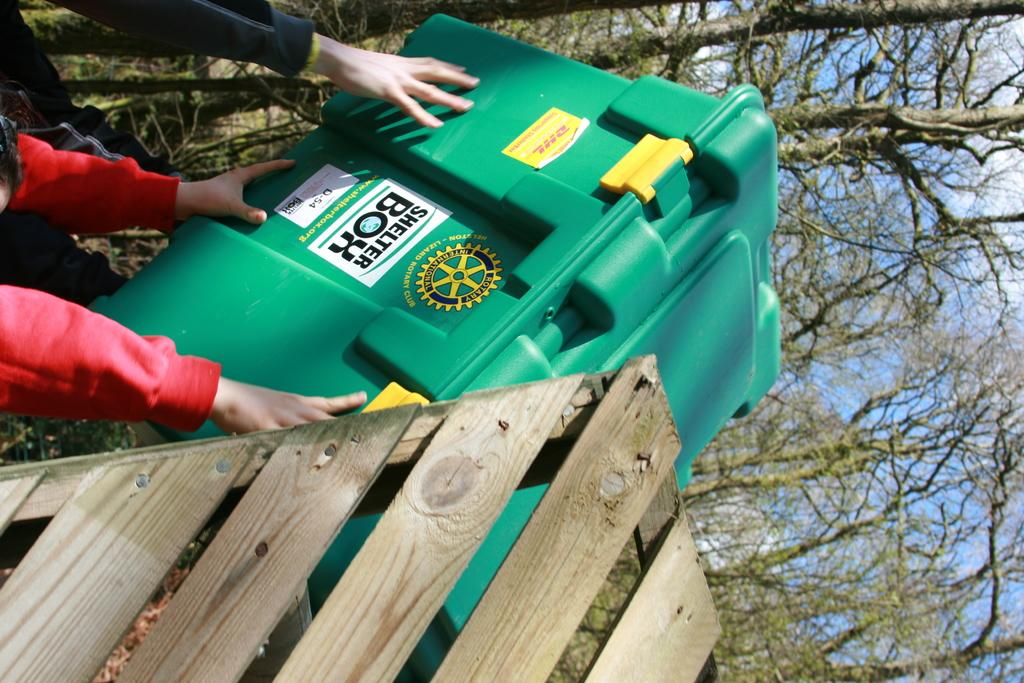What is located on the left side of the image? There is a shelter box on the left side of the image. Can you describe the people visible in the image? There are people visible in the image, but their specific actions or characteristics are not mentioned in the provided facts. What can be seen in the background of the image? There are trees in the background of the image. What type of toy can be seen in the history section of the image? There is no toy or history section present in the image; it features a shelter box and people with trees in the background. 